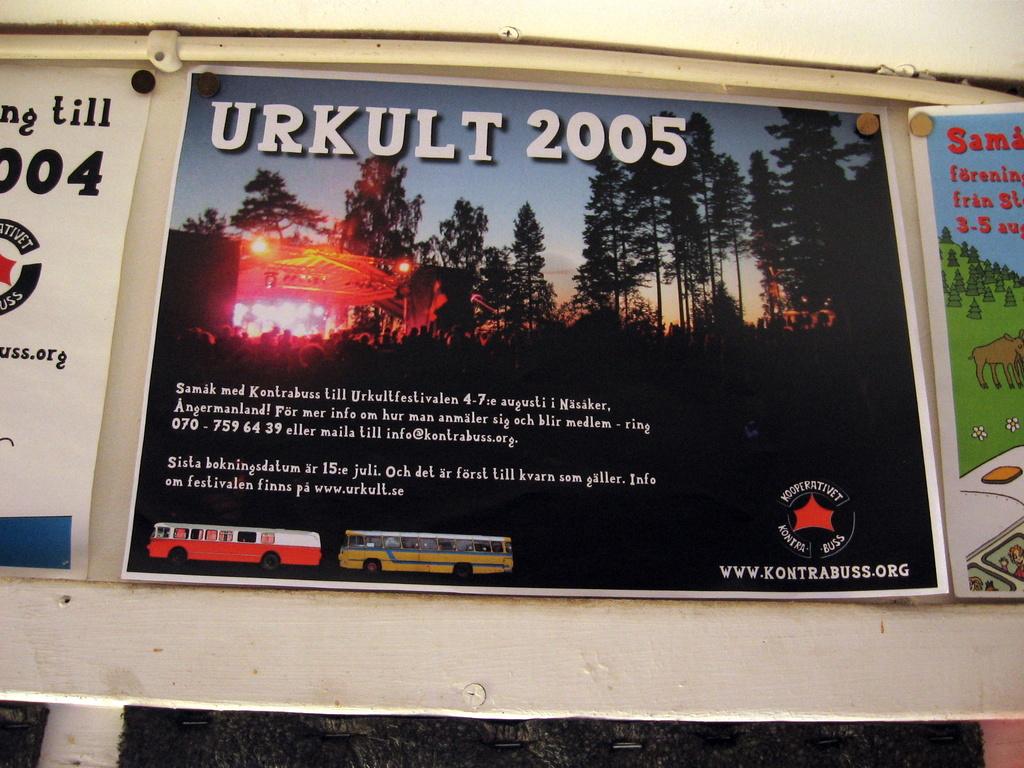What year is this event?
Your answer should be very brief. 2005. What year is shown in the poster?
Ensure brevity in your answer.  2005. 